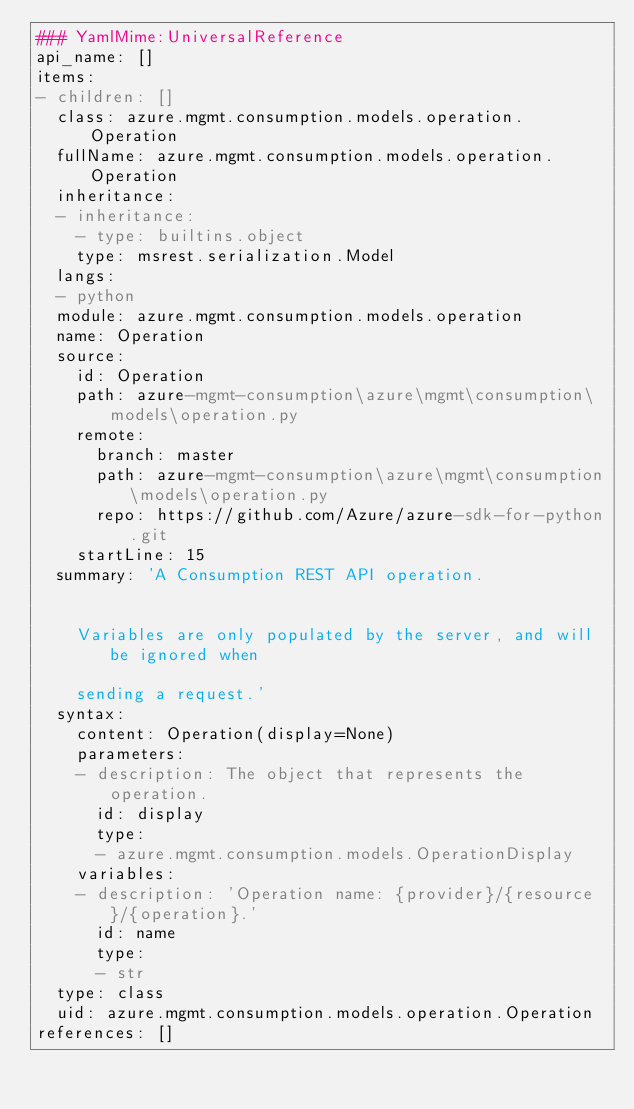Convert code to text. <code><loc_0><loc_0><loc_500><loc_500><_YAML_>### YamlMime:UniversalReference
api_name: []
items:
- children: []
  class: azure.mgmt.consumption.models.operation.Operation
  fullName: azure.mgmt.consumption.models.operation.Operation
  inheritance:
  - inheritance:
    - type: builtins.object
    type: msrest.serialization.Model
  langs:
  - python
  module: azure.mgmt.consumption.models.operation
  name: Operation
  source:
    id: Operation
    path: azure-mgmt-consumption\azure\mgmt\consumption\models\operation.py
    remote:
      branch: master
      path: azure-mgmt-consumption\azure\mgmt\consumption\models\operation.py
      repo: https://github.com/Azure/azure-sdk-for-python.git
    startLine: 15
  summary: 'A Consumption REST API operation.


    Variables are only populated by the server, and will be ignored when

    sending a request.'
  syntax:
    content: Operation(display=None)
    parameters:
    - description: The object that represents the operation.
      id: display
      type:
      - azure.mgmt.consumption.models.OperationDisplay
    variables:
    - description: 'Operation name: {provider}/{resource}/{operation}.'
      id: name
      type:
      - str
  type: class
  uid: azure.mgmt.consumption.models.operation.Operation
references: []
</code> 